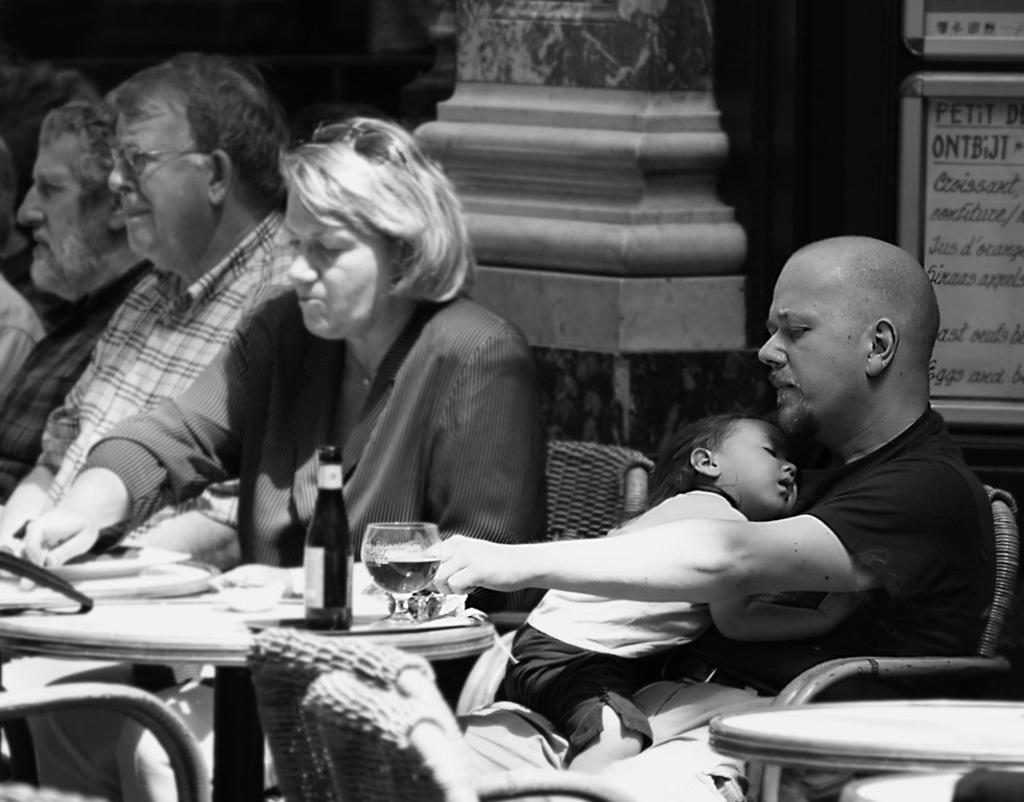What are the people in the image doing? There are people sitting on chairs in the image. What objects can be seen on the table in the image? There is a glass, a bowl, and a bottle on the table in the image. What is the man in the image doing? The man is holding a child in the image. Where are the man and child sitting in the image? The man and child are sitting on a chair in the image. What type of liquid is contained within the glass in the image? There is no information about the contents of the glass in the image, so it cannot be determined. What boundary is visible in the image? There is no boundary present in the image. 